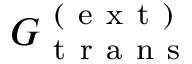Convert formula to latex. <formula><loc_0><loc_0><loc_500><loc_500>G _ { t r a n s } ^ { ( e x t ) }</formula> 